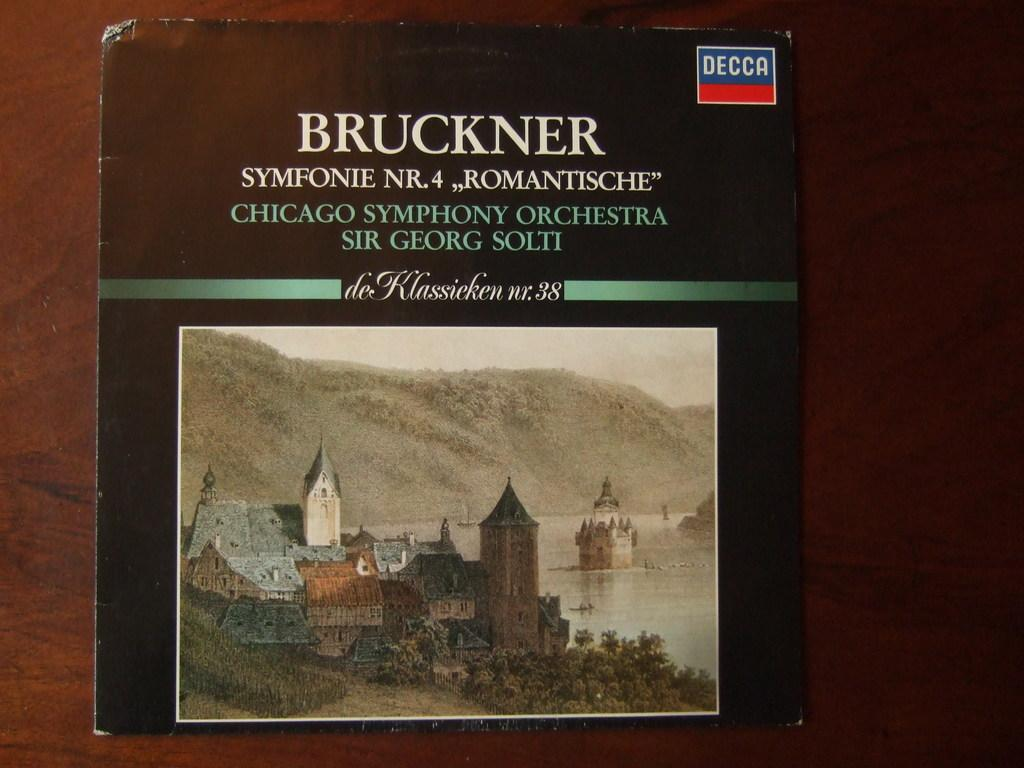<image>
Give a short and clear explanation of the subsequent image. a vinyl case for bruckner symfonie NR.4 with an illustration of a small village on the bottom. 